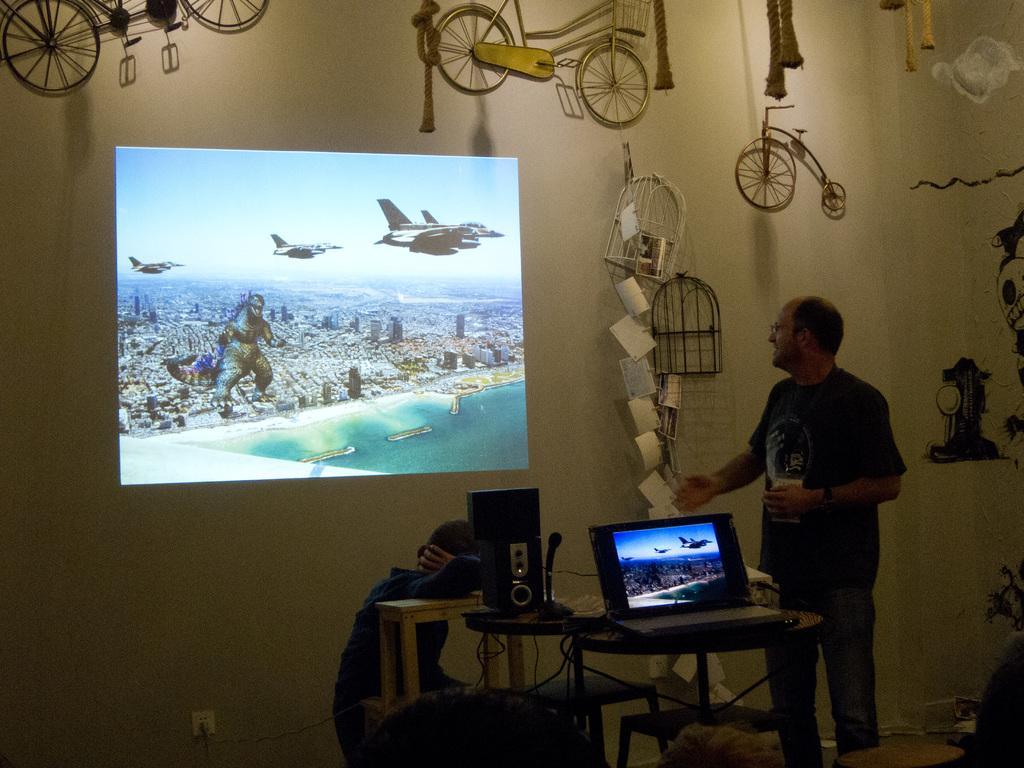Describe this image in one or two sentences. In this picture, we have 2 persons. In the right the person is standing and he is looking at the projection present there on the wall. And here we have table. On the table we have laptop, speakers. From the laptop the projection is made on the wall and we have bicycle toys present and here at the top we have audience viewing the picture. 